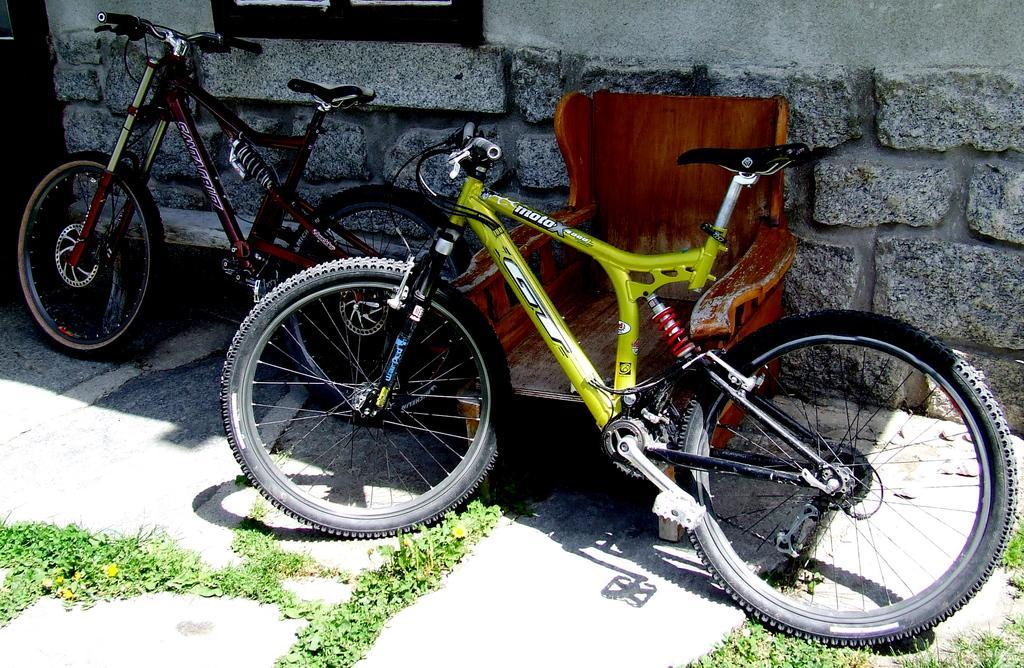Can you describe this image briefly? In this image in front there are two cycles and a chair. Behind them there is a wall. Beside the wall there is a door. At the bottom there is grass on the surface. 